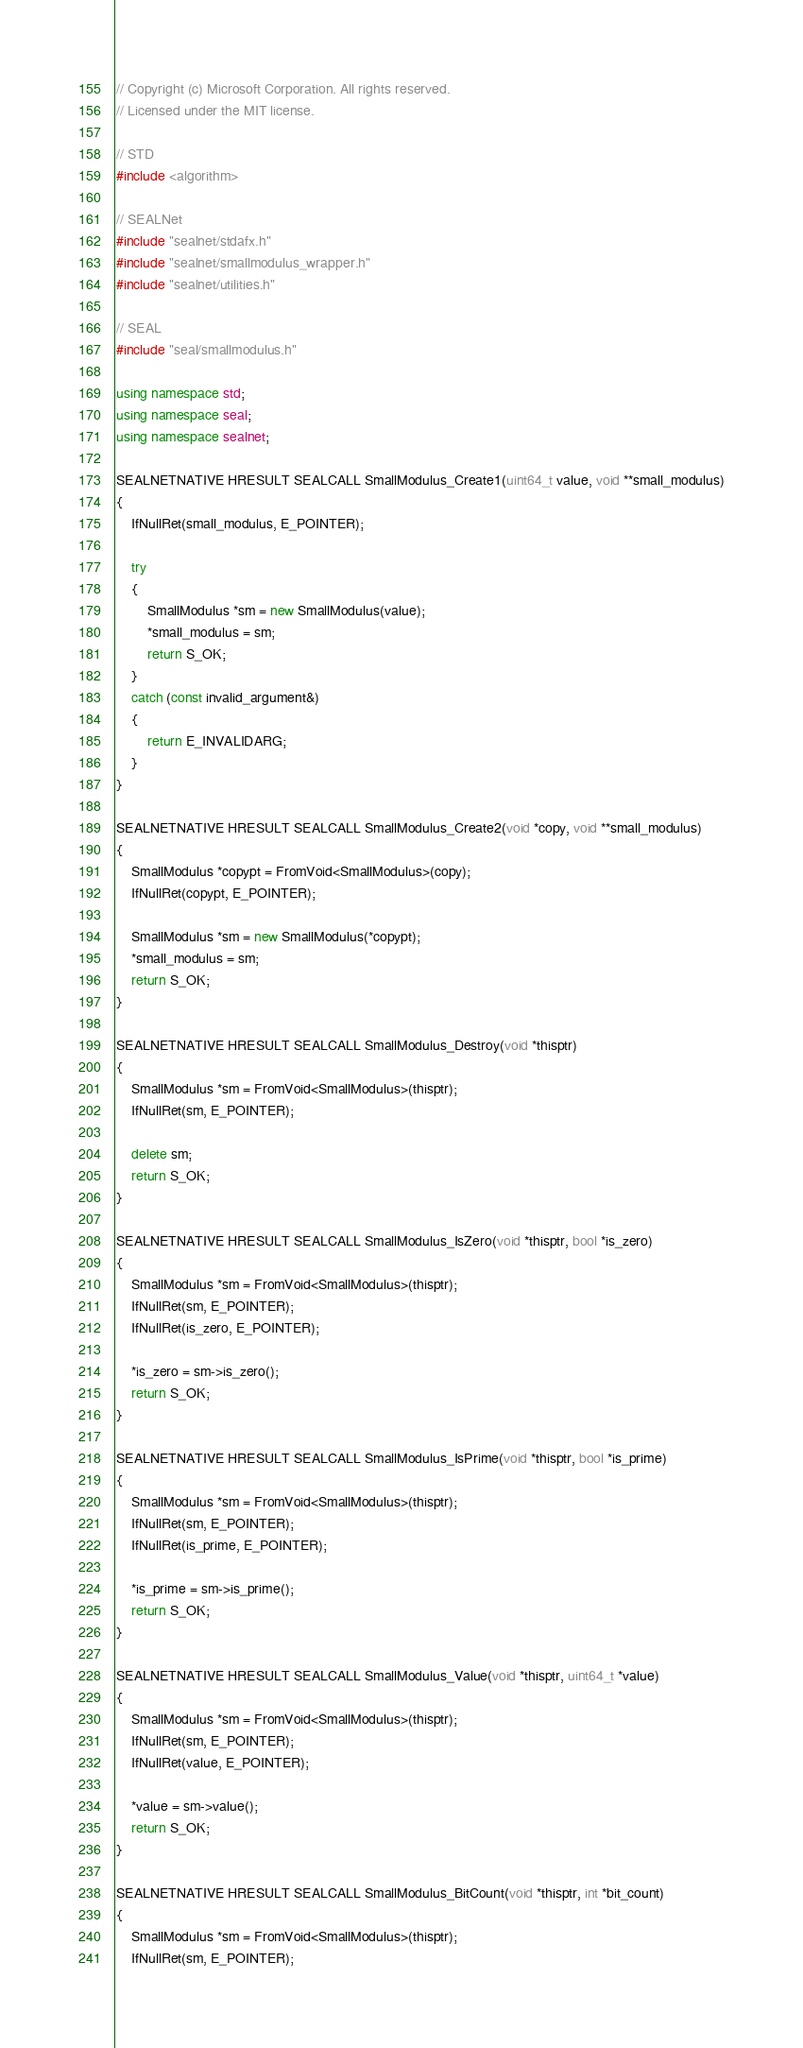Convert code to text. <code><loc_0><loc_0><loc_500><loc_500><_C++_>// Copyright (c) Microsoft Corporation. All rights reserved.
// Licensed under the MIT license.

// STD
#include <algorithm>

// SEALNet
#include "sealnet/stdafx.h"
#include "sealnet/smallmodulus_wrapper.h"
#include "sealnet/utilities.h"

// SEAL
#include "seal/smallmodulus.h"

using namespace std;
using namespace seal;
using namespace sealnet;

SEALNETNATIVE HRESULT SEALCALL SmallModulus_Create1(uint64_t value, void **small_modulus)
{
    IfNullRet(small_modulus, E_POINTER);

    try
    {
        SmallModulus *sm = new SmallModulus(value);
        *small_modulus = sm;
        return S_OK;
    }
    catch (const invalid_argument&)
    {
        return E_INVALIDARG;
    }
}

SEALNETNATIVE HRESULT SEALCALL SmallModulus_Create2(void *copy, void **small_modulus)
{
    SmallModulus *copypt = FromVoid<SmallModulus>(copy);
    IfNullRet(copypt, E_POINTER);

    SmallModulus *sm = new SmallModulus(*copypt);
    *small_modulus = sm;
    return S_OK;
}

SEALNETNATIVE HRESULT SEALCALL SmallModulus_Destroy(void *thisptr)
{
    SmallModulus *sm = FromVoid<SmallModulus>(thisptr);
    IfNullRet(sm, E_POINTER);

    delete sm;
    return S_OK;
}

SEALNETNATIVE HRESULT SEALCALL SmallModulus_IsZero(void *thisptr, bool *is_zero)
{
    SmallModulus *sm = FromVoid<SmallModulus>(thisptr);
    IfNullRet(sm, E_POINTER);
    IfNullRet(is_zero, E_POINTER);

    *is_zero = sm->is_zero();
    return S_OK;
}

SEALNETNATIVE HRESULT SEALCALL SmallModulus_IsPrime(void *thisptr, bool *is_prime)
{
    SmallModulus *sm = FromVoid<SmallModulus>(thisptr);
    IfNullRet(sm, E_POINTER);
    IfNullRet(is_prime, E_POINTER);

    *is_prime = sm->is_prime();
    return S_OK;
}

SEALNETNATIVE HRESULT SEALCALL SmallModulus_Value(void *thisptr, uint64_t *value)
{
    SmallModulus *sm = FromVoid<SmallModulus>(thisptr);
    IfNullRet(sm, E_POINTER);
    IfNullRet(value, E_POINTER);

    *value = sm->value();
    return S_OK;
}

SEALNETNATIVE HRESULT SEALCALL SmallModulus_BitCount(void *thisptr, int *bit_count)
{
    SmallModulus *sm = FromVoid<SmallModulus>(thisptr);
    IfNullRet(sm, E_POINTER);</code> 